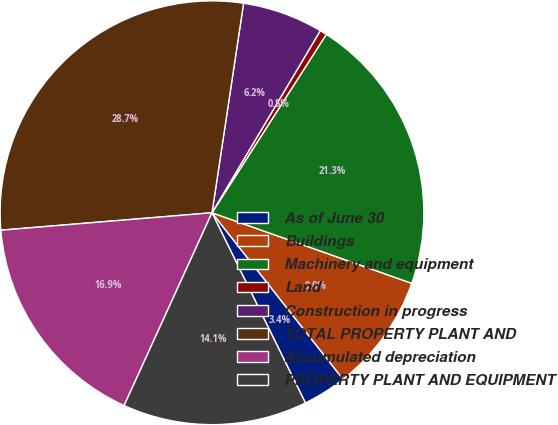<chart> <loc_0><loc_0><loc_500><loc_500><pie_chart><fcel>As of June 30<fcel>Buildings<fcel>Machinery and equipment<fcel>Land<fcel>Construction in progress<fcel>TOTAL PROPERTY PLANT AND<fcel>Accumulated depreciation<fcel>PROPERTY PLANT AND EQUIPMENT<nl><fcel>3.35%<fcel>8.98%<fcel>21.33%<fcel>0.53%<fcel>6.16%<fcel>28.69%<fcel>16.88%<fcel>14.07%<nl></chart> 